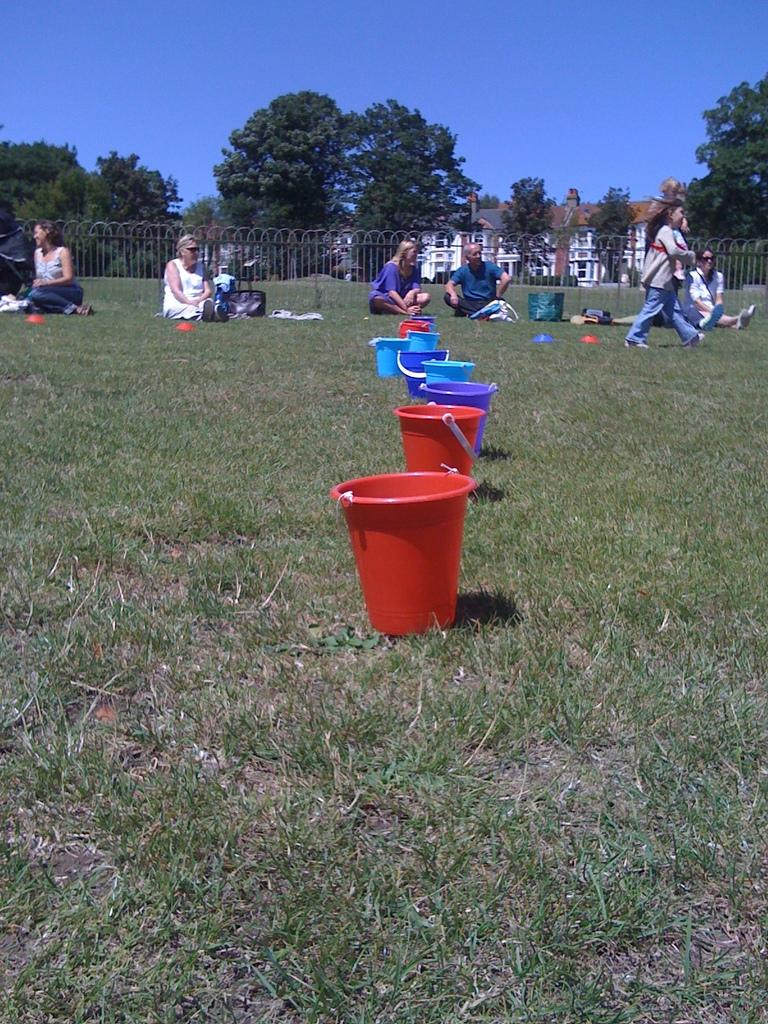What type of vegetation is present in the image? There is grass in the image. What objects can be seen in the image? There are buckets in the image. Who or what is present in the image? There is a group of people in the image. What structure is visible in the image? There is a fence in the image. What else can be seen in the image? There are trees in the image. What is visible at the top of the image? The sky is visible at the top of the image. What can be seen in the background of the image? There are buildings in the background of the image. Where is the tent located in the image? There is no tent present in the image. What type of loss is depicted in the image? There is no loss depicted in the image; it features grass, buckets, a group of people, a fence, trees, the sky, and buildings in the background. 